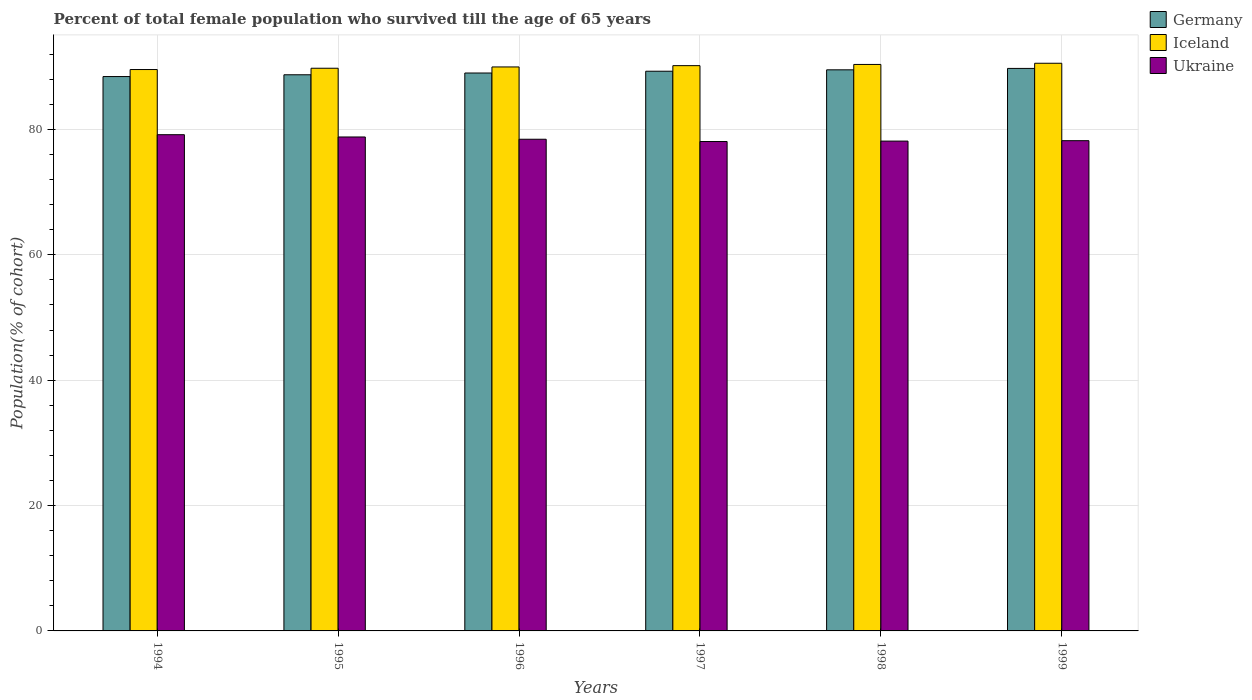How many groups of bars are there?
Provide a succinct answer. 6. Are the number of bars on each tick of the X-axis equal?
Ensure brevity in your answer.  Yes. How many bars are there on the 6th tick from the right?
Your answer should be compact. 3. What is the label of the 3rd group of bars from the left?
Your answer should be very brief. 1996. What is the percentage of total female population who survived till the age of 65 years in Ukraine in 1997?
Offer a terse response. 78.08. Across all years, what is the maximum percentage of total female population who survived till the age of 65 years in Iceland?
Ensure brevity in your answer.  90.57. Across all years, what is the minimum percentage of total female population who survived till the age of 65 years in Iceland?
Offer a very short reply. 89.56. In which year was the percentage of total female population who survived till the age of 65 years in Ukraine minimum?
Your answer should be very brief. 1997. What is the total percentage of total female population who survived till the age of 65 years in Germany in the graph?
Offer a very short reply. 534.75. What is the difference between the percentage of total female population who survived till the age of 65 years in Germany in 1995 and that in 1998?
Your answer should be very brief. -0.79. What is the difference between the percentage of total female population who survived till the age of 65 years in Ukraine in 1997 and the percentage of total female population who survived till the age of 65 years in Germany in 1996?
Give a very brief answer. -10.93. What is the average percentage of total female population who survived till the age of 65 years in Germany per year?
Give a very brief answer. 89.12. In the year 1999, what is the difference between the percentage of total female population who survived till the age of 65 years in Ukraine and percentage of total female population who survived till the age of 65 years in Germany?
Provide a succinct answer. -11.53. In how many years, is the percentage of total female population who survived till the age of 65 years in Iceland greater than 12 %?
Your answer should be compact. 6. What is the ratio of the percentage of total female population who survived till the age of 65 years in Iceland in 1994 to that in 1997?
Make the answer very short. 0.99. Is the percentage of total female population who survived till the age of 65 years in Germany in 1994 less than that in 1998?
Keep it short and to the point. Yes. What is the difference between the highest and the second highest percentage of total female population who survived till the age of 65 years in Germany?
Keep it short and to the point. 0.22. What is the difference between the highest and the lowest percentage of total female population who survived till the age of 65 years in Iceland?
Ensure brevity in your answer.  1. In how many years, is the percentage of total female population who survived till the age of 65 years in Germany greater than the average percentage of total female population who survived till the age of 65 years in Germany taken over all years?
Offer a terse response. 3. Is the sum of the percentage of total female population who survived till the age of 65 years in Germany in 1997 and 1998 greater than the maximum percentage of total female population who survived till the age of 65 years in Iceland across all years?
Provide a succinct answer. Yes. What does the 3rd bar from the left in 1995 represents?
Provide a short and direct response. Ukraine. What does the 2nd bar from the right in 1999 represents?
Offer a terse response. Iceland. Are all the bars in the graph horizontal?
Your response must be concise. No. How many years are there in the graph?
Offer a very short reply. 6. Does the graph contain grids?
Provide a short and direct response. Yes. Where does the legend appear in the graph?
Make the answer very short. Top right. How many legend labels are there?
Keep it short and to the point. 3. How are the legend labels stacked?
Provide a succinct answer. Vertical. What is the title of the graph?
Offer a terse response. Percent of total female population who survived till the age of 65 years. What is the label or title of the X-axis?
Give a very brief answer. Years. What is the label or title of the Y-axis?
Your response must be concise. Population(% of cohort). What is the Population(% of cohort) of Germany in 1994?
Provide a short and direct response. 88.45. What is the Population(% of cohort) in Iceland in 1994?
Your response must be concise. 89.56. What is the Population(% of cohort) in Ukraine in 1994?
Give a very brief answer. 79.17. What is the Population(% of cohort) in Germany in 1995?
Your answer should be very brief. 88.73. What is the Population(% of cohort) in Iceland in 1995?
Your response must be concise. 89.77. What is the Population(% of cohort) of Ukraine in 1995?
Your response must be concise. 78.81. What is the Population(% of cohort) of Germany in 1996?
Your answer should be very brief. 89.01. What is the Population(% of cohort) of Iceland in 1996?
Your answer should be very brief. 89.98. What is the Population(% of cohort) of Ukraine in 1996?
Offer a terse response. 78.44. What is the Population(% of cohort) of Germany in 1997?
Give a very brief answer. 89.3. What is the Population(% of cohort) in Iceland in 1997?
Make the answer very short. 90.19. What is the Population(% of cohort) in Ukraine in 1997?
Offer a terse response. 78.08. What is the Population(% of cohort) in Germany in 1998?
Make the answer very short. 89.52. What is the Population(% of cohort) of Iceland in 1998?
Your response must be concise. 90.38. What is the Population(% of cohort) of Ukraine in 1998?
Provide a short and direct response. 78.15. What is the Population(% of cohort) of Germany in 1999?
Keep it short and to the point. 89.75. What is the Population(% of cohort) of Iceland in 1999?
Your response must be concise. 90.57. What is the Population(% of cohort) of Ukraine in 1999?
Make the answer very short. 78.22. Across all years, what is the maximum Population(% of cohort) of Germany?
Provide a succinct answer. 89.75. Across all years, what is the maximum Population(% of cohort) of Iceland?
Provide a succinct answer. 90.57. Across all years, what is the maximum Population(% of cohort) of Ukraine?
Ensure brevity in your answer.  79.17. Across all years, what is the minimum Population(% of cohort) of Germany?
Provide a short and direct response. 88.45. Across all years, what is the minimum Population(% of cohort) of Iceland?
Give a very brief answer. 89.56. Across all years, what is the minimum Population(% of cohort) in Ukraine?
Provide a short and direct response. 78.08. What is the total Population(% of cohort) of Germany in the graph?
Keep it short and to the point. 534.75. What is the total Population(% of cohort) in Iceland in the graph?
Your response must be concise. 540.45. What is the total Population(% of cohort) of Ukraine in the graph?
Offer a very short reply. 470.86. What is the difference between the Population(% of cohort) of Germany in 1994 and that in 1995?
Ensure brevity in your answer.  -0.28. What is the difference between the Population(% of cohort) of Iceland in 1994 and that in 1995?
Provide a short and direct response. -0.21. What is the difference between the Population(% of cohort) in Ukraine in 1994 and that in 1995?
Provide a short and direct response. 0.36. What is the difference between the Population(% of cohort) in Germany in 1994 and that in 1996?
Make the answer very short. -0.57. What is the difference between the Population(% of cohort) of Iceland in 1994 and that in 1996?
Offer a very short reply. -0.41. What is the difference between the Population(% of cohort) in Ukraine in 1994 and that in 1996?
Provide a short and direct response. 0.73. What is the difference between the Population(% of cohort) in Germany in 1994 and that in 1997?
Keep it short and to the point. -0.85. What is the difference between the Population(% of cohort) of Iceland in 1994 and that in 1997?
Your answer should be compact. -0.62. What is the difference between the Population(% of cohort) in Ukraine in 1994 and that in 1997?
Ensure brevity in your answer.  1.09. What is the difference between the Population(% of cohort) in Germany in 1994 and that in 1998?
Offer a terse response. -1.07. What is the difference between the Population(% of cohort) of Iceland in 1994 and that in 1998?
Offer a very short reply. -0.81. What is the difference between the Population(% of cohort) of Ukraine in 1994 and that in 1998?
Make the answer very short. 1.02. What is the difference between the Population(% of cohort) of Germany in 1994 and that in 1999?
Provide a short and direct response. -1.3. What is the difference between the Population(% of cohort) of Iceland in 1994 and that in 1999?
Keep it short and to the point. -1. What is the difference between the Population(% of cohort) of Ukraine in 1994 and that in 1999?
Make the answer very short. 0.95. What is the difference between the Population(% of cohort) of Germany in 1995 and that in 1996?
Your answer should be very brief. -0.28. What is the difference between the Population(% of cohort) in Iceland in 1995 and that in 1996?
Provide a succinct answer. -0.21. What is the difference between the Population(% of cohort) in Ukraine in 1995 and that in 1996?
Provide a short and direct response. 0.36. What is the difference between the Population(% of cohort) of Germany in 1995 and that in 1997?
Your answer should be compact. -0.57. What is the difference between the Population(% of cohort) in Iceland in 1995 and that in 1997?
Make the answer very short. -0.41. What is the difference between the Population(% of cohort) of Ukraine in 1995 and that in 1997?
Make the answer very short. 0.73. What is the difference between the Population(% of cohort) in Germany in 1995 and that in 1998?
Make the answer very short. -0.79. What is the difference between the Population(% of cohort) in Iceland in 1995 and that in 1998?
Your response must be concise. -0.6. What is the difference between the Population(% of cohort) in Ukraine in 1995 and that in 1998?
Keep it short and to the point. 0.66. What is the difference between the Population(% of cohort) in Germany in 1995 and that in 1999?
Offer a terse response. -1.02. What is the difference between the Population(% of cohort) in Iceland in 1995 and that in 1999?
Your answer should be very brief. -0.8. What is the difference between the Population(% of cohort) of Ukraine in 1995 and that in 1999?
Your response must be concise. 0.59. What is the difference between the Population(% of cohort) in Germany in 1996 and that in 1997?
Provide a short and direct response. -0.28. What is the difference between the Population(% of cohort) of Iceland in 1996 and that in 1997?
Your answer should be compact. -0.21. What is the difference between the Population(% of cohort) of Ukraine in 1996 and that in 1997?
Offer a terse response. 0.36. What is the difference between the Population(% of cohort) in Germany in 1996 and that in 1998?
Make the answer very short. -0.51. What is the difference between the Population(% of cohort) in Iceland in 1996 and that in 1998?
Offer a terse response. -0.4. What is the difference between the Population(% of cohort) of Ukraine in 1996 and that in 1998?
Keep it short and to the point. 0.3. What is the difference between the Population(% of cohort) in Germany in 1996 and that in 1999?
Give a very brief answer. -0.73. What is the difference between the Population(% of cohort) of Iceland in 1996 and that in 1999?
Keep it short and to the point. -0.59. What is the difference between the Population(% of cohort) in Ukraine in 1996 and that in 1999?
Ensure brevity in your answer.  0.23. What is the difference between the Population(% of cohort) in Germany in 1997 and that in 1998?
Your response must be concise. -0.22. What is the difference between the Population(% of cohort) of Iceland in 1997 and that in 1998?
Your answer should be very brief. -0.19. What is the difference between the Population(% of cohort) in Ukraine in 1997 and that in 1998?
Provide a short and direct response. -0.07. What is the difference between the Population(% of cohort) of Germany in 1997 and that in 1999?
Make the answer very short. -0.45. What is the difference between the Population(% of cohort) in Iceland in 1997 and that in 1999?
Offer a very short reply. -0.38. What is the difference between the Population(% of cohort) in Ukraine in 1997 and that in 1999?
Provide a short and direct response. -0.13. What is the difference between the Population(% of cohort) in Germany in 1998 and that in 1999?
Keep it short and to the point. -0.22. What is the difference between the Population(% of cohort) in Iceland in 1998 and that in 1999?
Make the answer very short. -0.19. What is the difference between the Population(% of cohort) of Ukraine in 1998 and that in 1999?
Offer a very short reply. -0.07. What is the difference between the Population(% of cohort) in Germany in 1994 and the Population(% of cohort) in Iceland in 1995?
Make the answer very short. -1.33. What is the difference between the Population(% of cohort) of Germany in 1994 and the Population(% of cohort) of Ukraine in 1995?
Your response must be concise. 9.64. What is the difference between the Population(% of cohort) in Iceland in 1994 and the Population(% of cohort) in Ukraine in 1995?
Your answer should be very brief. 10.76. What is the difference between the Population(% of cohort) of Germany in 1994 and the Population(% of cohort) of Iceland in 1996?
Ensure brevity in your answer.  -1.53. What is the difference between the Population(% of cohort) in Germany in 1994 and the Population(% of cohort) in Ukraine in 1996?
Your response must be concise. 10. What is the difference between the Population(% of cohort) of Iceland in 1994 and the Population(% of cohort) of Ukraine in 1996?
Keep it short and to the point. 11.12. What is the difference between the Population(% of cohort) of Germany in 1994 and the Population(% of cohort) of Iceland in 1997?
Ensure brevity in your answer.  -1.74. What is the difference between the Population(% of cohort) in Germany in 1994 and the Population(% of cohort) in Ukraine in 1997?
Make the answer very short. 10.36. What is the difference between the Population(% of cohort) of Iceland in 1994 and the Population(% of cohort) of Ukraine in 1997?
Your response must be concise. 11.48. What is the difference between the Population(% of cohort) of Germany in 1994 and the Population(% of cohort) of Iceland in 1998?
Give a very brief answer. -1.93. What is the difference between the Population(% of cohort) in Germany in 1994 and the Population(% of cohort) in Ukraine in 1998?
Make the answer very short. 10.3. What is the difference between the Population(% of cohort) in Iceland in 1994 and the Population(% of cohort) in Ukraine in 1998?
Your answer should be very brief. 11.42. What is the difference between the Population(% of cohort) in Germany in 1994 and the Population(% of cohort) in Iceland in 1999?
Your answer should be very brief. -2.12. What is the difference between the Population(% of cohort) in Germany in 1994 and the Population(% of cohort) in Ukraine in 1999?
Ensure brevity in your answer.  10.23. What is the difference between the Population(% of cohort) in Iceland in 1994 and the Population(% of cohort) in Ukraine in 1999?
Your answer should be compact. 11.35. What is the difference between the Population(% of cohort) in Germany in 1995 and the Population(% of cohort) in Iceland in 1996?
Your response must be concise. -1.25. What is the difference between the Population(% of cohort) of Germany in 1995 and the Population(% of cohort) of Ukraine in 1996?
Your response must be concise. 10.29. What is the difference between the Population(% of cohort) of Iceland in 1995 and the Population(% of cohort) of Ukraine in 1996?
Give a very brief answer. 11.33. What is the difference between the Population(% of cohort) in Germany in 1995 and the Population(% of cohort) in Iceland in 1997?
Keep it short and to the point. -1.46. What is the difference between the Population(% of cohort) of Germany in 1995 and the Population(% of cohort) of Ukraine in 1997?
Your answer should be very brief. 10.65. What is the difference between the Population(% of cohort) of Iceland in 1995 and the Population(% of cohort) of Ukraine in 1997?
Provide a short and direct response. 11.69. What is the difference between the Population(% of cohort) of Germany in 1995 and the Population(% of cohort) of Iceland in 1998?
Offer a terse response. -1.65. What is the difference between the Population(% of cohort) in Germany in 1995 and the Population(% of cohort) in Ukraine in 1998?
Make the answer very short. 10.58. What is the difference between the Population(% of cohort) of Iceland in 1995 and the Population(% of cohort) of Ukraine in 1998?
Ensure brevity in your answer.  11.62. What is the difference between the Population(% of cohort) of Germany in 1995 and the Population(% of cohort) of Iceland in 1999?
Make the answer very short. -1.84. What is the difference between the Population(% of cohort) in Germany in 1995 and the Population(% of cohort) in Ukraine in 1999?
Make the answer very short. 10.51. What is the difference between the Population(% of cohort) in Iceland in 1995 and the Population(% of cohort) in Ukraine in 1999?
Your answer should be very brief. 11.56. What is the difference between the Population(% of cohort) in Germany in 1996 and the Population(% of cohort) in Iceland in 1997?
Provide a short and direct response. -1.17. What is the difference between the Population(% of cohort) in Germany in 1996 and the Population(% of cohort) in Ukraine in 1997?
Your response must be concise. 10.93. What is the difference between the Population(% of cohort) in Iceland in 1996 and the Population(% of cohort) in Ukraine in 1997?
Give a very brief answer. 11.9. What is the difference between the Population(% of cohort) of Germany in 1996 and the Population(% of cohort) of Iceland in 1998?
Your response must be concise. -1.36. What is the difference between the Population(% of cohort) in Germany in 1996 and the Population(% of cohort) in Ukraine in 1998?
Keep it short and to the point. 10.86. What is the difference between the Population(% of cohort) in Iceland in 1996 and the Population(% of cohort) in Ukraine in 1998?
Ensure brevity in your answer.  11.83. What is the difference between the Population(% of cohort) of Germany in 1996 and the Population(% of cohort) of Iceland in 1999?
Provide a succinct answer. -1.55. What is the difference between the Population(% of cohort) in Germany in 1996 and the Population(% of cohort) in Ukraine in 1999?
Offer a very short reply. 10.8. What is the difference between the Population(% of cohort) of Iceland in 1996 and the Population(% of cohort) of Ukraine in 1999?
Offer a very short reply. 11.76. What is the difference between the Population(% of cohort) of Germany in 1997 and the Population(% of cohort) of Iceland in 1998?
Give a very brief answer. -1.08. What is the difference between the Population(% of cohort) in Germany in 1997 and the Population(% of cohort) in Ukraine in 1998?
Keep it short and to the point. 11.15. What is the difference between the Population(% of cohort) of Iceland in 1997 and the Population(% of cohort) of Ukraine in 1998?
Offer a very short reply. 12.04. What is the difference between the Population(% of cohort) of Germany in 1997 and the Population(% of cohort) of Iceland in 1999?
Make the answer very short. -1.27. What is the difference between the Population(% of cohort) of Germany in 1997 and the Population(% of cohort) of Ukraine in 1999?
Offer a very short reply. 11.08. What is the difference between the Population(% of cohort) of Iceland in 1997 and the Population(% of cohort) of Ukraine in 1999?
Your answer should be very brief. 11.97. What is the difference between the Population(% of cohort) of Germany in 1998 and the Population(% of cohort) of Iceland in 1999?
Your response must be concise. -1.05. What is the difference between the Population(% of cohort) in Germany in 1998 and the Population(% of cohort) in Ukraine in 1999?
Your answer should be compact. 11.31. What is the difference between the Population(% of cohort) in Iceland in 1998 and the Population(% of cohort) in Ukraine in 1999?
Your response must be concise. 12.16. What is the average Population(% of cohort) in Germany per year?
Offer a terse response. 89.12. What is the average Population(% of cohort) in Iceland per year?
Ensure brevity in your answer.  90.07. What is the average Population(% of cohort) in Ukraine per year?
Keep it short and to the point. 78.48. In the year 1994, what is the difference between the Population(% of cohort) in Germany and Population(% of cohort) in Iceland?
Provide a succinct answer. -1.12. In the year 1994, what is the difference between the Population(% of cohort) of Germany and Population(% of cohort) of Ukraine?
Make the answer very short. 9.28. In the year 1994, what is the difference between the Population(% of cohort) in Iceland and Population(% of cohort) in Ukraine?
Offer a very short reply. 10.39. In the year 1995, what is the difference between the Population(% of cohort) in Germany and Population(% of cohort) in Iceland?
Your answer should be very brief. -1.04. In the year 1995, what is the difference between the Population(% of cohort) in Germany and Population(% of cohort) in Ukraine?
Offer a terse response. 9.92. In the year 1995, what is the difference between the Population(% of cohort) of Iceland and Population(% of cohort) of Ukraine?
Offer a terse response. 10.96. In the year 1996, what is the difference between the Population(% of cohort) of Germany and Population(% of cohort) of Iceland?
Your answer should be compact. -0.97. In the year 1996, what is the difference between the Population(% of cohort) in Germany and Population(% of cohort) in Ukraine?
Ensure brevity in your answer.  10.57. In the year 1996, what is the difference between the Population(% of cohort) of Iceland and Population(% of cohort) of Ukraine?
Your answer should be very brief. 11.54. In the year 1997, what is the difference between the Population(% of cohort) of Germany and Population(% of cohort) of Iceland?
Your answer should be compact. -0.89. In the year 1997, what is the difference between the Population(% of cohort) of Germany and Population(% of cohort) of Ukraine?
Offer a very short reply. 11.22. In the year 1997, what is the difference between the Population(% of cohort) in Iceland and Population(% of cohort) in Ukraine?
Give a very brief answer. 12.11. In the year 1998, what is the difference between the Population(% of cohort) in Germany and Population(% of cohort) in Iceland?
Your answer should be compact. -0.86. In the year 1998, what is the difference between the Population(% of cohort) in Germany and Population(% of cohort) in Ukraine?
Offer a very short reply. 11.37. In the year 1998, what is the difference between the Population(% of cohort) of Iceland and Population(% of cohort) of Ukraine?
Your answer should be very brief. 12.23. In the year 1999, what is the difference between the Population(% of cohort) of Germany and Population(% of cohort) of Iceland?
Your answer should be compact. -0.82. In the year 1999, what is the difference between the Population(% of cohort) in Germany and Population(% of cohort) in Ukraine?
Provide a short and direct response. 11.53. In the year 1999, what is the difference between the Population(% of cohort) of Iceland and Population(% of cohort) of Ukraine?
Make the answer very short. 12.35. What is the ratio of the Population(% of cohort) in Germany in 1994 to that in 1995?
Your answer should be very brief. 1. What is the ratio of the Population(% of cohort) in Iceland in 1994 to that in 1995?
Offer a terse response. 1. What is the ratio of the Population(% of cohort) of Germany in 1994 to that in 1996?
Offer a terse response. 0.99. What is the ratio of the Population(% of cohort) of Iceland in 1994 to that in 1996?
Give a very brief answer. 1. What is the ratio of the Population(% of cohort) of Ukraine in 1994 to that in 1996?
Offer a very short reply. 1.01. What is the ratio of the Population(% of cohort) in Germany in 1994 to that in 1997?
Your response must be concise. 0.99. What is the ratio of the Population(% of cohort) in Ukraine in 1994 to that in 1997?
Provide a succinct answer. 1.01. What is the ratio of the Population(% of cohort) in Ukraine in 1994 to that in 1998?
Your answer should be very brief. 1.01. What is the ratio of the Population(% of cohort) in Germany in 1994 to that in 1999?
Your answer should be compact. 0.99. What is the ratio of the Population(% of cohort) in Iceland in 1994 to that in 1999?
Keep it short and to the point. 0.99. What is the ratio of the Population(% of cohort) of Ukraine in 1994 to that in 1999?
Make the answer very short. 1.01. What is the ratio of the Population(% of cohort) in Germany in 1995 to that in 1996?
Keep it short and to the point. 1. What is the ratio of the Population(% of cohort) in Ukraine in 1995 to that in 1996?
Ensure brevity in your answer.  1. What is the ratio of the Population(% of cohort) of Ukraine in 1995 to that in 1997?
Give a very brief answer. 1.01. What is the ratio of the Population(% of cohort) in Ukraine in 1995 to that in 1998?
Your answer should be very brief. 1.01. What is the ratio of the Population(% of cohort) of Germany in 1995 to that in 1999?
Provide a succinct answer. 0.99. What is the ratio of the Population(% of cohort) in Ukraine in 1995 to that in 1999?
Offer a terse response. 1.01. What is the ratio of the Population(% of cohort) in Germany in 1996 to that in 1997?
Offer a very short reply. 1. What is the ratio of the Population(% of cohort) of Iceland in 1996 to that in 1997?
Offer a terse response. 1. What is the ratio of the Population(% of cohort) in Ukraine in 1996 to that in 1997?
Your response must be concise. 1. What is the ratio of the Population(% of cohort) of Iceland in 1996 to that in 1998?
Ensure brevity in your answer.  1. What is the ratio of the Population(% of cohort) of Germany in 1996 to that in 1999?
Keep it short and to the point. 0.99. What is the ratio of the Population(% of cohort) of Iceland in 1996 to that in 1999?
Provide a succinct answer. 0.99. What is the ratio of the Population(% of cohort) of Ukraine in 1996 to that in 1999?
Your response must be concise. 1. What is the ratio of the Population(% of cohort) in Germany in 1997 to that in 1999?
Your answer should be compact. 0.99. What is the ratio of the Population(% of cohort) in Germany in 1998 to that in 1999?
Your answer should be compact. 1. What is the ratio of the Population(% of cohort) of Iceland in 1998 to that in 1999?
Make the answer very short. 1. What is the difference between the highest and the second highest Population(% of cohort) in Germany?
Offer a terse response. 0.22. What is the difference between the highest and the second highest Population(% of cohort) of Iceland?
Your answer should be compact. 0.19. What is the difference between the highest and the second highest Population(% of cohort) in Ukraine?
Give a very brief answer. 0.36. What is the difference between the highest and the lowest Population(% of cohort) of Germany?
Offer a very short reply. 1.3. What is the difference between the highest and the lowest Population(% of cohort) in Ukraine?
Give a very brief answer. 1.09. 